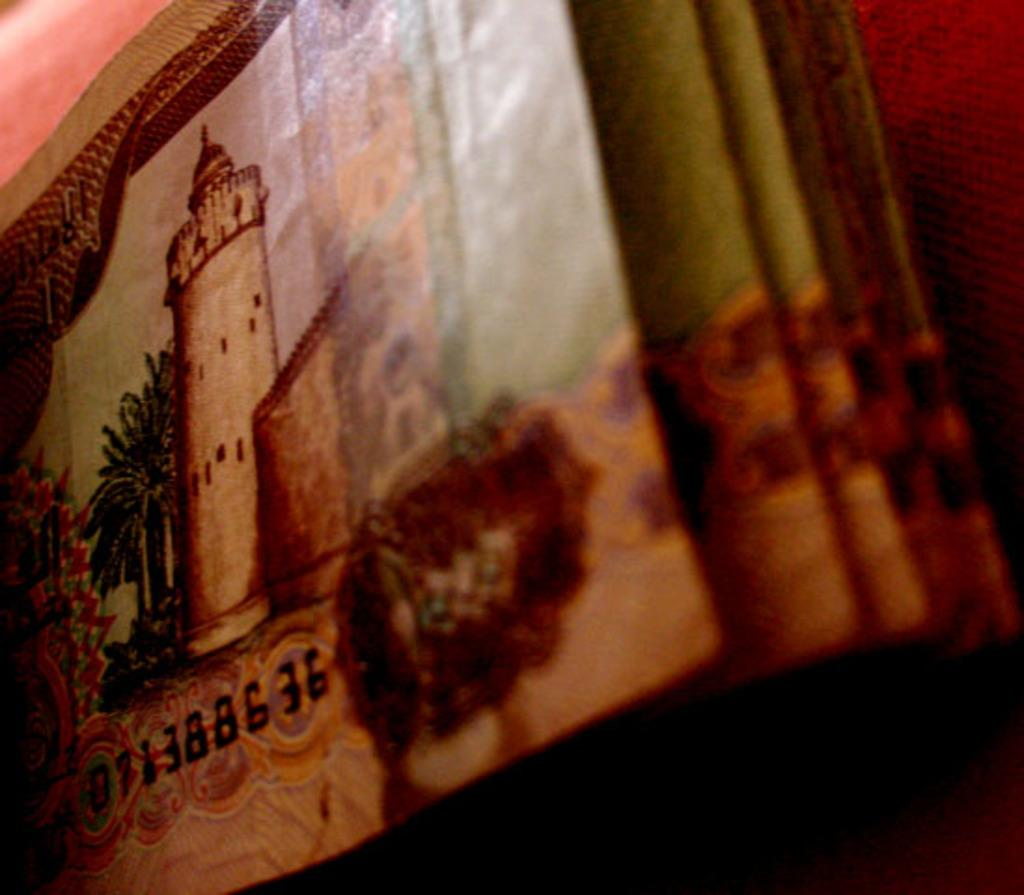<image>
Offer a succinct explanation of the picture presented. A stack of money has a bill with the serial number 071388636. 